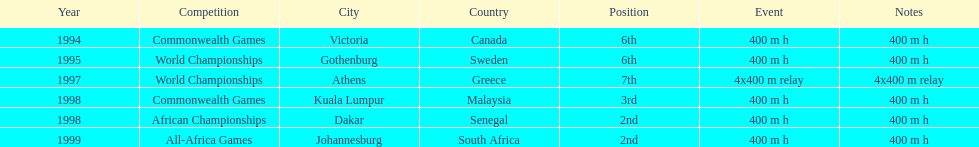In what year did ken harnden participate in more than one competition? 1998. 